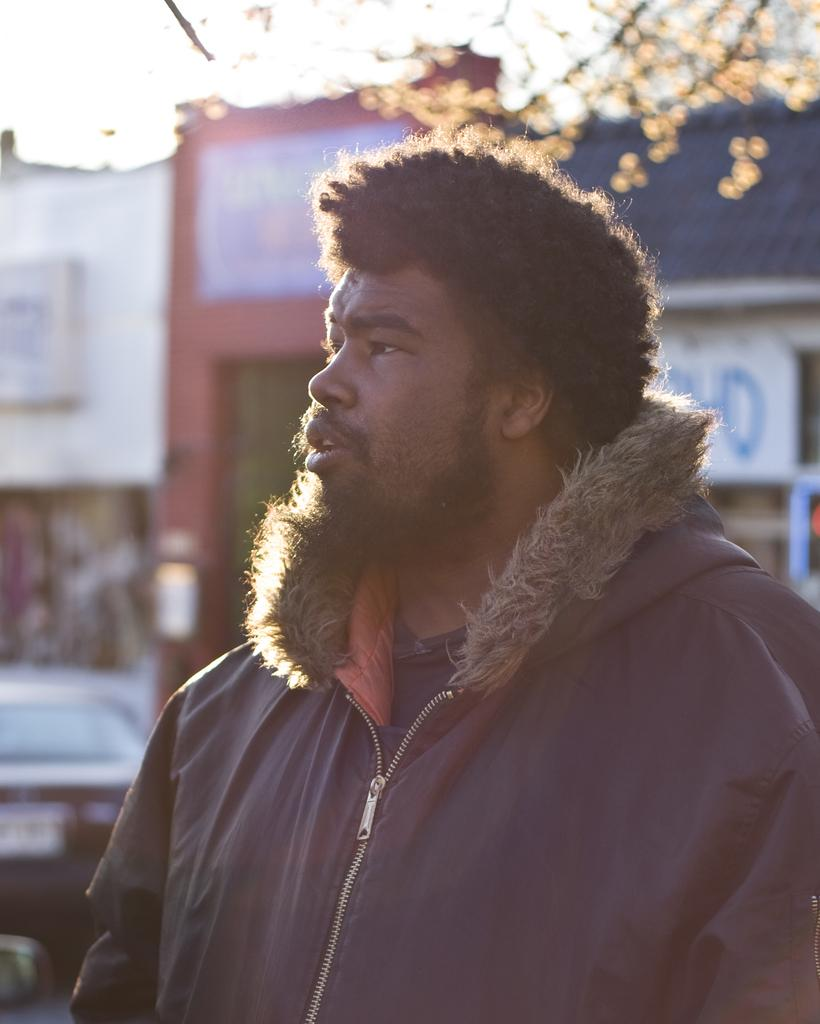What is the main subject of the image? There is a man standing in the center of the image. What is the man wearing? The man is wearing a jacket. What can be seen in the background of the image? There are buildings and a tree visible in the background of the image. What type of celery is the man holding in the image? There is no celery present in the image. Is the man using a fan to cool himself down in the image? There is no fan visible in the image. 